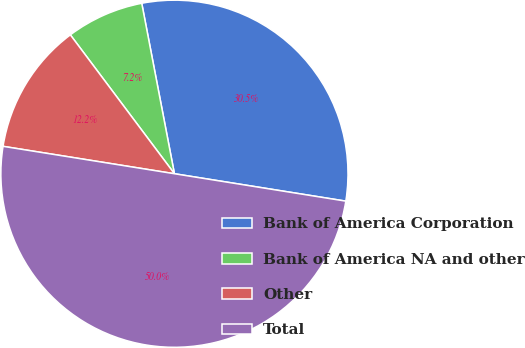<chart> <loc_0><loc_0><loc_500><loc_500><pie_chart><fcel>Bank of America Corporation<fcel>Bank of America NA and other<fcel>Other<fcel>Total<nl><fcel>30.54%<fcel>7.22%<fcel>12.24%<fcel>50.0%<nl></chart> 